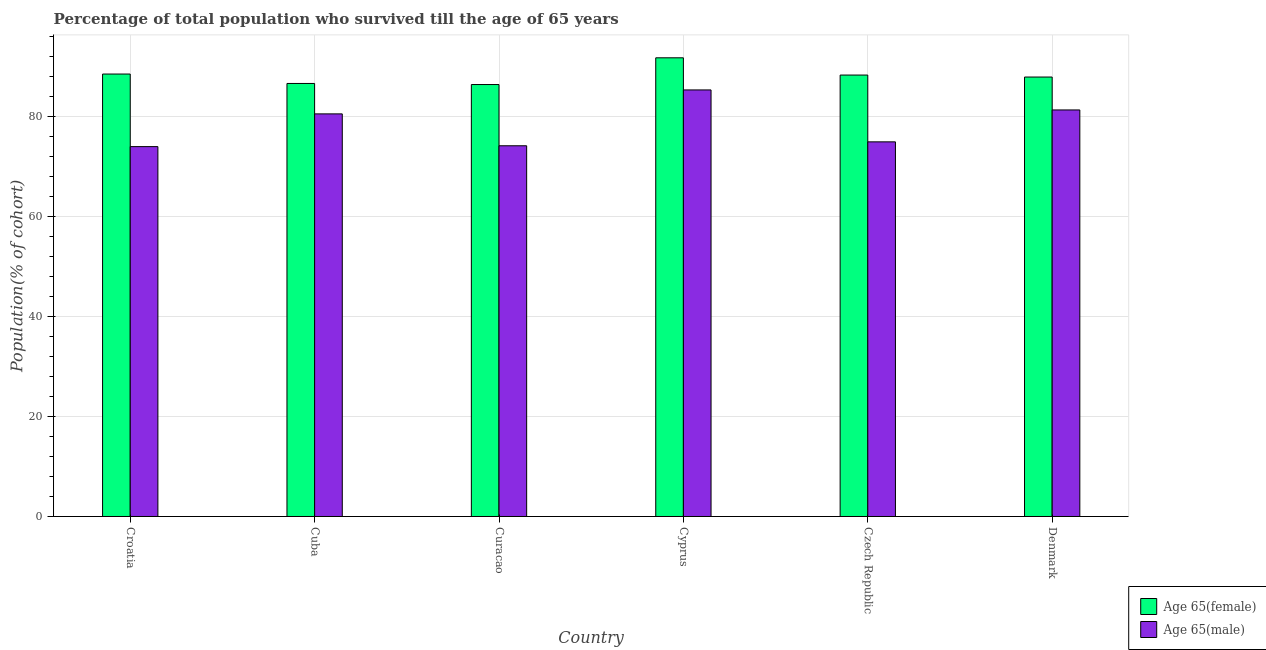How many different coloured bars are there?
Your response must be concise. 2. Are the number of bars on each tick of the X-axis equal?
Offer a very short reply. Yes. How many bars are there on the 3rd tick from the left?
Your response must be concise. 2. How many bars are there on the 3rd tick from the right?
Provide a short and direct response. 2. What is the label of the 5th group of bars from the left?
Your answer should be very brief. Czech Republic. In how many cases, is the number of bars for a given country not equal to the number of legend labels?
Provide a succinct answer. 0. What is the percentage of female population who survived till age of 65 in Denmark?
Your response must be concise. 87.87. Across all countries, what is the maximum percentage of female population who survived till age of 65?
Your response must be concise. 91.71. Across all countries, what is the minimum percentage of male population who survived till age of 65?
Your answer should be compact. 73.95. In which country was the percentage of female population who survived till age of 65 maximum?
Keep it short and to the point. Cyprus. In which country was the percentage of male population who survived till age of 65 minimum?
Offer a very short reply. Croatia. What is the total percentage of male population who survived till age of 65 in the graph?
Provide a short and direct response. 470.05. What is the difference between the percentage of female population who survived till age of 65 in Cuba and that in Czech Republic?
Your response must be concise. -1.68. What is the difference between the percentage of female population who survived till age of 65 in Croatia and the percentage of male population who survived till age of 65 in Cuba?
Offer a terse response. 7.97. What is the average percentage of male population who survived till age of 65 per country?
Keep it short and to the point. 78.34. What is the difference between the percentage of female population who survived till age of 65 and percentage of male population who survived till age of 65 in Cuba?
Keep it short and to the point. 6.08. In how many countries, is the percentage of male population who survived till age of 65 greater than 88 %?
Your response must be concise. 0. What is the ratio of the percentage of female population who survived till age of 65 in Croatia to that in Cuba?
Offer a terse response. 1.02. What is the difference between the highest and the second highest percentage of male population who survived till age of 65?
Ensure brevity in your answer.  4. What is the difference between the highest and the lowest percentage of female population who survived till age of 65?
Your answer should be very brief. 5.34. What does the 1st bar from the left in Curacao represents?
Give a very brief answer. Age 65(female). What does the 1st bar from the right in Croatia represents?
Keep it short and to the point. Age 65(male). How many countries are there in the graph?
Your answer should be very brief. 6. Does the graph contain any zero values?
Give a very brief answer. No. What is the title of the graph?
Your response must be concise. Percentage of total population who survived till the age of 65 years. What is the label or title of the X-axis?
Give a very brief answer. Country. What is the label or title of the Y-axis?
Make the answer very short. Population(% of cohort). What is the Population(% of cohort) of Age 65(female) in Croatia?
Offer a terse response. 88.47. What is the Population(% of cohort) in Age 65(male) in Croatia?
Give a very brief answer. 73.95. What is the Population(% of cohort) of Age 65(female) in Cuba?
Your answer should be very brief. 86.58. What is the Population(% of cohort) in Age 65(male) in Cuba?
Provide a succinct answer. 80.5. What is the Population(% of cohort) in Age 65(female) in Curacao?
Offer a terse response. 86.37. What is the Population(% of cohort) of Age 65(male) in Curacao?
Give a very brief answer. 74.12. What is the Population(% of cohort) of Age 65(female) in Cyprus?
Give a very brief answer. 91.71. What is the Population(% of cohort) in Age 65(male) in Cyprus?
Make the answer very short. 85.29. What is the Population(% of cohort) in Age 65(female) in Czech Republic?
Provide a succinct answer. 88.26. What is the Population(% of cohort) of Age 65(male) in Czech Republic?
Offer a terse response. 74.91. What is the Population(% of cohort) in Age 65(female) in Denmark?
Provide a succinct answer. 87.87. What is the Population(% of cohort) of Age 65(male) in Denmark?
Offer a very short reply. 81.29. Across all countries, what is the maximum Population(% of cohort) in Age 65(female)?
Provide a short and direct response. 91.71. Across all countries, what is the maximum Population(% of cohort) of Age 65(male)?
Ensure brevity in your answer.  85.29. Across all countries, what is the minimum Population(% of cohort) of Age 65(female)?
Offer a very short reply. 86.37. Across all countries, what is the minimum Population(% of cohort) of Age 65(male)?
Your response must be concise. 73.95. What is the total Population(% of cohort) of Age 65(female) in the graph?
Give a very brief answer. 529.26. What is the total Population(% of cohort) of Age 65(male) in the graph?
Offer a very short reply. 470.05. What is the difference between the Population(% of cohort) of Age 65(female) in Croatia and that in Cuba?
Provide a short and direct response. 1.88. What is the difference between the Population(% of cohort) of Age 65(male) in Croatia and that in Cuba?
Your answer should be compact. -6.55. What is the difference between the Population(% of cohort) of Age 65(female) in Croatia and that in Curacao?
Provide a succinct answer. 2.1. What is the difference between the Population(% of cohort) of Age 65(male) in Croatia and that in Curacao?
Keep it short and to the point. -0.17. What is the difference between the Population(% of cohort) of Age 65(female) in Croatia and that in Cyprus?
Your answer should be very brief. -3.25. What is the difference between the Population(% of cohort) of Age 65(male) in Croatia and that in Cyprus?
Offer a terse response. -11.33. What is the difference between the Population(% of cohort) of Age 65(female) in Croatia and that in Czech Republic?
Your answer should be very brief. 0.2. What is the difference between the Population(% of cohort) of Age 65(male) in Croatia and that in Czech Republic?
Your response must be concise. -0.95. What is the difference between the Population(% of cohort) in Age 65(female) in Croatia and that in Denmark?
Keep it short and to the point. 0.6. What is the difference between the Population(% of cohort) of Age 65(male) in Croatia and that in Denmark?
Provide a short and direct response. -7.33. What is the difference between the Population(% of cohort) of Age 65(female) in Cuba and that in Curacao?
Make the answer very short. 0.22. What is the difference between the Population(% of cohort) in Age 65(male) in Cuba and that in Curacao?
Your answer should be very brief. 6.38. What is the difference between the Population(% of cohort) of Age 65(female) in Cuba and that in Cyprus?
Give a very brief answer. -5.13. What is the difference between the Population(% of cohort) in Age 65(male) in Cuba and that in Cyprus?
Provide a short and direct response. -4.79. What is the difference between the Population(% of cohort) in Age 65(female) in Cuba and that in Czech Republic?
Offer a terse response. -1.68. What is the difference between the Population(% of cohort) of Age 65(male) in Cuba and that in Czech Republic?
Give a very brief answer. 5.59. What is the difference between the Population(% of cohort) in Age 65(female) in Cuba and that in Denmark?
Ensure brevity in your answer.  -1.28. What is the difference between the Population(% of cohort) in Age 65(male) in Cuba and that in Denmark?
Your answer should be compact. -0.79. What is the difference between the Population(% of cohort) in Age 65(female) in Curacao and that in Cyprus?
Provide a succinct answer. -5.34. What is the difference between the Population(% of cohort) in Age 65(male) in Curacao and that in Cyprus?
Your response must be concise. -11.17. What is the difference between the Population(% of cohort) in Age 65(female) in Curacao and that in Czech Republic?
Your answer should be compact. -1.89. What is the difference between the Population(% of cohort) in Age 65(male) in Curacao and that in Czech Republic?
Offer a very short reply. -0.78. What is the difference between the Population(% of cohort) in Age 65(female) in Curacao and that in Denmark?
Make the answer very short. -1.5. What is the difference between the Population(% of cohort) of Age 65(male) in Curacao and that in Denmark?
Your response must be concise. -7.16. What is the difference between the Population(% of cohort) in Age 65(female) in Cyprus and that in Czech Republic?
Your answer should be compact. 3.45. What is the difference between the Population(% of cohort) in Age 65(male) in Cyprus and that in Czech Republic?
Offer a very short reply. 10.38. What is the difference between the Population(% of cohort) of Age 65(female) in Cyprus and that in Denmark?
Your answer should be very brief. 3.84. What is the difference between the Population(% of cohort) of Age 65(male) in Cyprus and that in Denmark?
Your answer should be compact. 4. What is the difference between the Population(% of cohort) in Age 65(female) in Czech Republic and that in Denmark?
Provide a succinct answer. 0.4. What is the difference between the Population(% of cohort) in Age 65(male) in Czech Republic and that in Denmark?
Your answer should be compact. -6.38. What is the difference between the Population(% of cohort) in Age 65(female) in Croatia and the Population(% of cohort) in Age 65(male) in Cuba?
Offer a terse response. 7.97. What is the difference between the Population(% of cohort) of Age 65(female) in Croatia and the Population(% of cohort) of Age 65(male) in Curacao?
Provide a short and direct response. 14.34. What is the difference between the Population(% of cohort) in Age 65(female) in Croatia and the Population(% of cohort) in Age 65(male) in Cyprus?
Your answer should be very brief. 3.18. What is the difference between the Population(% of cohort) in Age 65(female) in Croatia and the Population(% of cohort) in Age 65(male) in Czech Republic?
Your answer should be very brief. 13.56. What is the difference between the Population(% of cohort) of Age 65(female) in Croatia and the Population(% of cohort) of Age 65(male) in Denmark?
Make the answer very short. 7.18. What is the difference between the Population(% of cohort) in Age 65(female) in Cuba and the Population(% of cohort) in Age 65(male) in Curacao?
Offer a terse response. 12.46. What is the difference between the Population(% of cohort) in Age 65(female) in Cuba and the Population(% of cohort) in Age 65(male) in Cyprus?
Provide a succinct answer. 1.29. What is the difference between the Population(% of cohort) of Age 65(female) in Cuba and the Population(% of cohort) of Age 65(male) in Czech Republic?
Keep it short and to the point. 11.68. What is the difference between the Population(% of cohort) in Age 65(female) in Cuba and the Population(% of cohort) in Age 65(male) in Denmark?
Keep it short and to the point. 5.3. What is the difference between the Population(% of cohort) in Age 65(female) in Curacao and the Population(% of cohort) in Age 65(male) in Cyprus?
Make the answer very short. 1.08. What is the difference between the Population(% of cohort) of Age 65(female) in Curacao and the Population(% of cohort) of Age 65(male) in Czech Republic?
Your answer should be compact. 11.46. What is the difference between the Population(% of cohort) of Age 65(female) in Curacao and the Population(% of cohort) of Age 65(male) in Denmark?
Offer a terse response. 5.08. What is the difference between the Population(% of cohort) in Age 65(female) in Cyprus and the Population(% of cohort) in Age 65(male) in Czech Republic?
Your answer should be very brief. 16.81. What is the difference between the Population(% of cohort) in Age 65(female) in Cyprus and the Population(% of cohort) in Age 65(male) in Denmark?
Give a very brief answer. 10.42. What is the difference between the Population(% of cohort) of Age 65(female) in Czech Republic and the Population(% of cohort) of Age 65(male) in Denmark?
Your answer should be compact. 6.98. What is the average Population(% of cohort) of Age 65(female) per country?
Give a very brief answer. 88.21. What is the average Population(% of cohort) of Age 65(male) per country?
Offer a very short reply. 78.34. What is the difference between the Population(% of cohort) of Age 65(female) and Population(% of cohort) of Age 65(male) in Croatia?
Ensure brevity in your answer.  14.51. What is the difference between the Population(% of cohort) of Age 65(female) and Population(% of cohort) of Age 65(male) in Cuba?
Give a very brief answer. 6.08. What is the difference between the Population(% of cohort) in Age 65(female) and Population(% of cohort) in Age 65(male) in Curacao?
Your answer should be very brief. 12.25. What is the difference between the Population(% of cohort) in Age 65(female) and Population(% of cohort) in Age 65(male) in Cyprus?
Give a very brief answer. 6.42. What is the difference between the Population(% of cohort) in Age 65(female) and Population(% of cohort) in Age 65(male) in Czech Republic?
Your response must be concise. 13.36. What is the difference between the Population(% of cohort) of Age 65(female) and Population(% of cohort) of Age 65(male) in Denmark?
Ensure brevity in your answer.  6.58. What is the ratio of the Population(% of cohort) of Age 65(female) in Croatia to that in Cuba?
Ensure brevity in your answer.  1.02. What is the ratio of the Population(% of cohort) in Age 65(male) in Croatia to that in Cuba?
Give a very brief answer. 0.92. What is the ratio of the Population(% of cohort) in Age 65(female) in Croatia to that in Curacao?
Ensure brevity in your answer.  1.02. What is the ratio of the Population(% of cohort) in Age 65(male) in Croatia to that in Curacao?
Provide a short and direct response. 1. What is the ratio of the Population(% of cohort) of Age 65(female) in Croatia to that in Cyprus?
Your answer should be compact. 0.96. What is the ratio of the Population(% of cohort) of Age 65(male) in Croatia to that in Cyprus?
Offer a very short reply. 0.87. What is the ratio of the Population(% of cohort) of Age 65(female) in Croatia to that in Czech Republic?
Ensure brevity in your answer.  1. What is the ratio of the Population(% of cohort) of Age 65(male) in Croatia to that in Czech Republic?
Keep it short and to the point. 0.99. What is the ratio of the Population(% of cohort) of Age 65(female) in Croatia to that in Denmark?
Offer a terse response. 1.01. What is the ratio of the Population(% of cohort) of Age 65(male) in Croatia to that in Denmark?
Provide a succinct answer. 0.91. What is the ratio of the Population(% of cohort) of Age 65(male) in Cuba to that in Curacao?
Provide a succinct answer. 1.09. What is the ratio of the Population(% of cohort) of Age 65(female) in Cuba to that in Cyprus?
Provide a succinct answer. 0.94. What is the ratio of the Population(% of cohort) of Age 65(male) in Cuba to that in Cyprus?
Offer a very short reply. 0.94. What is the ratio of the Population(% of cohort) in Age 65(male) in Cuba to that in Czech Republic?
Offer a terse response. 1.07. What is the ratio of the Population(% of cohort) of Age 65(female) in Cuba to that in Denmark?
Provide a short and direct response. 0.99. What is the ratio of the Population(% of cohort) in Age 65(male) in Cuba to that in Denmark?
Keep it short and to the point. 0.99. What is the ratio of the Population(% of cohort) in Age 65(female) in Curacao to that in Cyprus?
Your answer should be compact. 0.94. What is the ratio of the Population(% of cohort) in Age 65(male) in Curacao to that in Cyprus?
Ensure brevity in your answer.  0.87. What is the ratio of the Population(% of cohort) of Age 65(female) in Curacao to that in Czech Republic?
Give a very brief answer. 0.98. What is the ratio of the Population(% of cohort) of Age 65(male) in Curacao to that in Czech Republic?
Keep it short and to the point. 0.99. What is the ratio of the Population(% of cohort) in Age 65(female) in Curacao to that in Denmark?
Provide a succinct answer. 0.98. What is the ratio of the Population(% of cohort) of Age 65(male) in Curacao to that in Denmark?
Ensure brevity in your answer.  0.91. What is the ratio of the Population(% of cohort) of Age 65(female) in Cyprus to that in Czech Republic?
Give a very brief answer. 1.04. What is the ratio of the Population(% of cohort) of Age 65(male) in Cyprus to that in Czech Republic?
Your answer should be very brief. 1.14. What is the ratio of the Population(% of cohort) in Age 65(female) in Cyprus to that in Denmark?
Keep it short and to the point. 1.04. What is the ratio of the Population(% of cohort) of Age 65(male) in Cyprus to that in Denmark?
Offer a very short reply. 1.05. What is the ratio of the Population(% of cohort) in Age 65(female) in Czech Republic to that in Denmark?
Ensure brevity in your answer.  1. What is the ratio of the Population(% of cohort) in Age 65(male) in Czech Republic to that in Denmark?
Give a very brief answer. 0.92. What is the difference between the highest and the second highest Population(% of cohort) of Age 65(female)?
Offer a very short reply. 3.25. What is the difference between the highest and the second highest Population(% of cohort) in Age 65(male)?
Your answer should be compact. 4. What is the difference between the highest and the lowest Population(% of cohort) of Age 65(female)?
Provide a succinct answer. 5.34. What is the difference between the highest and the lowest Population(% of cohort) in Age 65(male)?
Give a very brief answer. 11.33. 